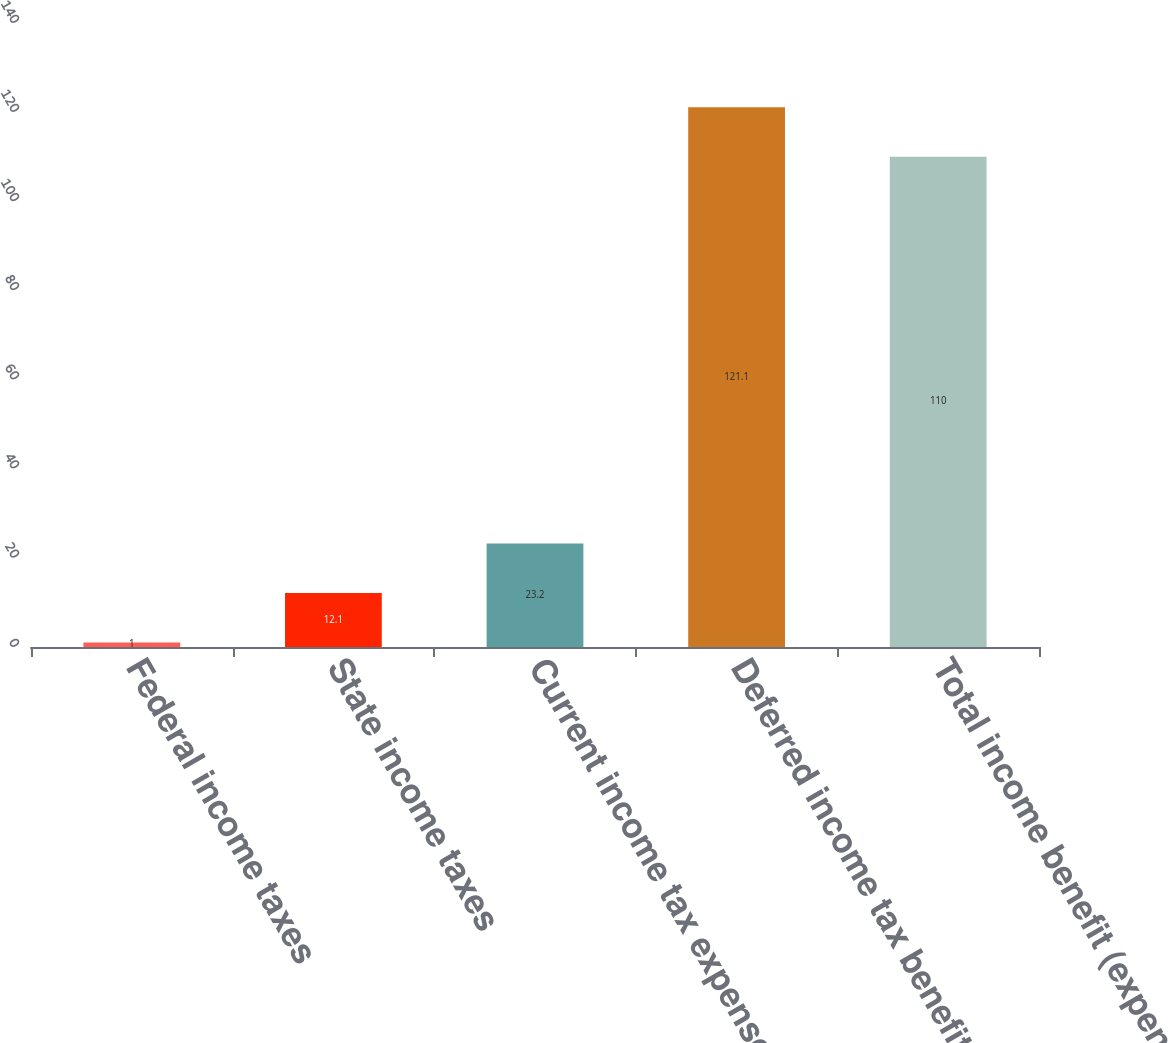<chart> <loc_0><loc_0><loc_500><loc_500><bar_chart><fcel>Federal income taxes<fcel>State income taxes<fcel>Current income tax expense<fcel>Deferred income tax benefit<fcel>Total income benefit (expense)<nl><fcel>1<fcel>12.1<fcel>23.2<fcel>121.1<fcel>110<nl></chart> 